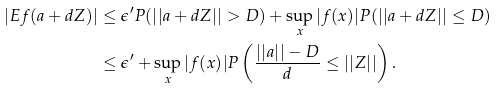<formula> <loc_0><loc_0><loc_500><loc_500>| E f ( a + d Z ) | & \leq \epsilon ^ { \prime } P ( | | a + d Z | | > D ) + \sup _ { x } | f ( x ) | P ( | | a + d Z | | \leq D ) \\ & \leq \epsilon ^ { \prime } + \sup _ { x } | f ( x ) | P \left ( \frac { | | a | | - D } { d } \leq | | Z | | \right ) .</formula> 